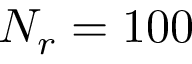<formula> <loc_0><loc_0><loc_500><loc_500>N _ { r } = 1 0 0</formula> 